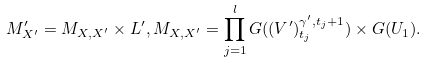<formula> <loc_0><loc_0><loc_500><loc_500>M ^ { \prime } _ { X ^ { \prime } } = M _ { X , X ^ { \prime } } \times L ^ { \prime } , M _ { X , X ^ { \prime } } = \prod _ { j = 1 } ^ { l } G ( ( V ^ { \prime } ) ^ { \gamma ^ { \prime } , t _ { j } + 1 } _ { t _ { j } } ) \times G ( U _ { 1 } ) .</formula> 